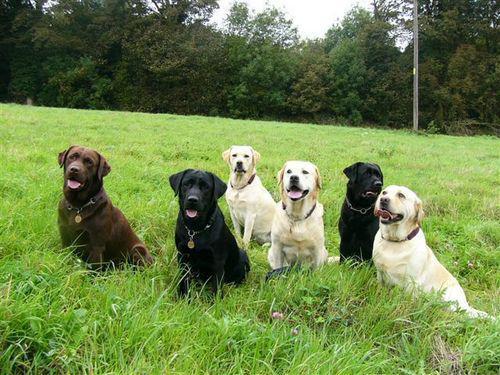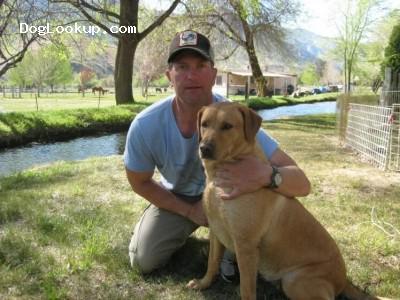The first image is the image on the left, the second image is the image on the right. Considering the images on both sides, is "At least four dogs in a grassy area have their mouths open and their tongues showing." valid? Answer yes or no. Yes. The first image is the image on the left, the second image is the image on the right. Considering the images on both sides, is "There are more dogs in the left image than in the right." valid? Answer yes or no. Yes. 